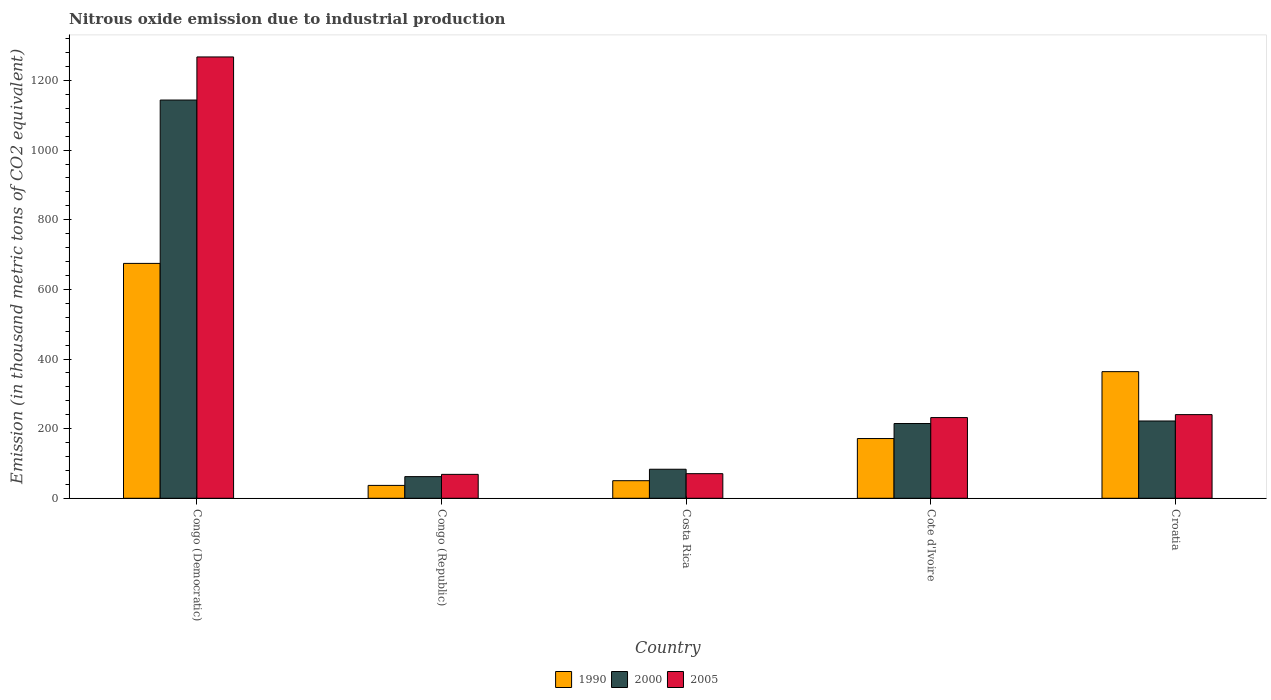Are the number of bars per tick equal to the number of legend labels?
Ensure brevity in your answer.  Yes. Are the number of bars on each tick of the X-axis equal?
Provide a short and direct response. Yes. What is the label of the 4th group of bars from the left?
Keep it short and to the point. Cote d'Ivoire. In how many cases, is the number of bars for a given country not equal to the number of legend labels?
Your answer should be very brief. 0. What is the amount of nitrous oxide emitted in 2000 in Congo (Democratic)?
Your answer should be compact. 1143.8. Across all countries, what is the maximum amount of nitrous oxide emitted in 2005?
Keep it short and to the point. 1267.6. Across all countries, what is the minimum amount of nitrous oxide emitted in 2005?
Your answer should be very brief. 68.7. In which country was the amount of nitrous oxide emitted in 1990 maximum?
Give a very brief answer. Congo (Democratic). In which country was the amount of nitrous oxide emitted in 1990 minimum?
Make the answer very short. Congo (Republic). What is the total amount of nitrous oxide emitted in 2005 in the graph?
Provide a succinct answer. 1879.1. What is the difference between the amount of nitrous oxide emitted in 2005 in Congo (Democratic) and that in Cote d'Ivoire?
Make the answer very short. 1035.8. What is the difference between the amount of nitrous oxide emitted in 2000 in Costa Rica and the amount of nitrous oxide emitted in 1990 in Congo (Republic)?
Keep it short and to the point. 46.4. What is the average amount of nitrous oxide emitted in 1990 per country?
Ensure brevity in your answer.  259.48. What is the difference between the amount of nitrous oxide emitted of/in 1990 and amount of nitrous oxide emitted of/in 2000 in Congo (Democratic)?
Ensure brevity in your answer.  -469.2. What is the ratio of the amount of nitrous oxide emitted in 2000 in Congo (Democratic) to that in Croatia?
Keep it short and to the point. 5.15. Is the amount of nitrous oxide emitted in 2005 in Congo (Democratic) less than that in Congo (Republic)?
Make the answer very short. No. Is the difference between the amount of nitrous oxide emitted in 1990 in Congo (Democratic) and Congo (Republic) greater than the difference between the amount of nitrous oxide emitted in 2000 in Congo (Democratic) and Congo (Republic)?
Offer a very short reply. No. What is the difference between the highest and the second highest amount of nitrous oxide emitted in 2000?
Offer a very short reply. -7.3. What is the difference between the highest and the lowest amount of nitrous oxide emitted in 2005?
Provide a succinct answer. 1198.9. Are all the bars in the graph horizontal?
Make the answer very short. No. What is the difference between two consecutive major ticks on the Y-axis?
Offer a terse response. 200. Are the values on the major ticks of Y-axis written in scientific E-notation?
Provide a short and direct response. No. Where does the legend appear in the graph?
Provide a short and direct response. Bottom center. How are the legend labels stacked?
Your answer should be very brief. Horizontal. What is the title of the graph?
Provide a short and direct response. Nitrous oxide emission due to industrial production. Does "1967" appear as one of the legend labels in the graph?
Provide a succinct answer. No. What is the label or title of the X-axis?
Make the answer very short. Country. What is the label or title of the Y-axis?
Your response must be concise. Emission (in thousand metric tons of CO2 equivalent). What is the Emission (in thousand metric tons of CO2 equivalent) in 1990 in Congo (Democratic)?
Offer a terse response. 674.6. What is the Emission (in thousand metric tons of CO2 equivalent) of 2000 in Congo (Democratic)?
Offer a very short reply. 1143.8. What is the Emission (in thousand metric tons of CO2 equivalent) in 2005 in Congo (Democratic)?
Provide a succinct answer. 1267.6. What is the Emission (in thousand metric tons of CO2 equivalent) in 1990 in Congo (Republic)?
Ensure brevity in your answer.  37. What is the Emission (in thousand metric tons of CO2 equivalent) of 2000 in Congo (Republic)?
Ensure brevity in your answer.  62.2. What is the Emission (in thousand metric tons of CO2 equivalent) in 2005 in Congo (Republic)?
Provide a short and direct response. 68.7. What is the Emission (in thousand metric tons of CO2 equivalent) of 1990 in Costa Rica?
Your response must be concise. 50.5. What is the Emission (in thousand metric tons of CO2 equivalent) of 2000 in Costa Rica?
Make the answer very short. 83.4. What is the Emission (in thousand metric tons of CO2 equivalent) in 2005 in Costa Rica?
Offer a very short reply. 70.7. What is the Emission (in thousand metric tons of CO2 equivalent) in 1990 in Cote d'Ivoire?
Offer a very short reply. 171.6. What is the Emission (in thousand metric tons of CO2 equivalent) in 2000 in Cote d'Ivoire?
Your answer should be compact. 214.7. What is the Emission (in thousand metric tons of CO2 equivalent) in 2005 in Cote d'Ivoire?
Your answer should be very brief. 231.8. What is the Emission (in thousand metric tons of CO2 equivalent) in 1990 in Croatia?
Ensure brevity in your answer.  363.7. What is the Emission (in thousand metric tons of CO2 equivalent) in 2000 in Croatia?
Give a very brief answer. 222. What is the Emission (in thousand metric tons of CO2 equivalent) in 2005 in Croatia?
Your response must be concise. 240.3. Across all countries, what is the maximum Emission (in thousand metric tons of CO2 equivalent) of 1990?
Ensure brevity in your answer.  674.6. Across all countries, what is the maximum Emission (in thousand metric tons of CO2 equivalent) in 2000?
Offer a very short reply. 1143.8. Across all countries, what is the maximum Emission (in thousand metric tons of CO2 equivalent) in 2005?
Offer a very short reply. 1267.6. Across all countries, what is the minimum Emission (in thousand metric tons of CO2 equivalent) of 2000?
Make the answer very short. 62.2. Across all countries, what is the minimum Emission (in thousand metric tons of CO2 equivalent) in 2005?
Your answer should be compact. 68.7. What is the total Emission (in thousand metric tons of CO2 equivalent) in 1990 in the graph?
Your answer should be very brief. 1297.4. What is the total Emission (in thousand metric tons of CO2 equivalent) of 2000 in the graph?
Ensure brevity in your answer.  1726.1. What is the total Emission (in thousand metric tons of CO2 equivalent) in 2005 in the graph?
Keep it short and to the point. 1879.1. What is the difference between the Emission (in thousand metric tons of CO2 equivalent) of 1990 in Congo (Democratic) and that in Congo (Republic)?
Offer a terse response. 637.6. What is the difference between the Emission (in thousand metric tons of CO2 equivalent) of 2000 in Congo (Democratic) and that in Congo (Republic)?
Keep it short and to the point. 1081.6. What is the difference between the Emission (in thousand metric tons of CO2 equivalent) in 2005 in Congo (Democratic) and that in Congo (Republic)?
Your answer should be very brief. 1198.9. What is the difference between the Emission (in thousand metric tons of CO2 equivalent) of 1990 in Congo (Democratic) and that in Costa Rica?
Make the answer very short. 624.1. What is the difference between the Emission (in thousand metric tons of CO2 equivalent) of 2000 in Congo (Democratic) and that in Costa Rica?
Offer a terse response. 1060.4. What is the difference between the Emission (in thousand metric tons of CO2 equivalent) in 2005 in Congo (Democratic) and that in Costa Rica?
Make the answer very short. 1196.9. What is the difference between the Emission (in thousand metric tons of CO2 equivalent) of 1990 in Congo (Democratic) and that in Cote d'Ivoire?
Your response must be concise. 503. What is the difference between the Emission (in thousand metric tons of CO2 equivalent) in 2000 in Congo (Democratic) and that in Cote d'Ivoire?
Provide a short and direct response. 929.1. What is the difference between the Emission (in thousand metric tons of CO2 equivalent) in 2005 in Congo (Democratic) and that in Cote d'Ivoire?
Keep it short and to the point. 1035.8. What is the difference between the Emission (in thousand metric tons of CO2 equivalent) of 1990 in Congo (Democratic) and that in Croatia?
Offer a very short reply. 310.9. What is the difference between the Emission (in thousand metric tons of CO2 equivalent) of 2000 in Congo (Democratic) and that in Croatia?
Keep it short and to the point. 921.8. What is the difference between the Emission (in thousand metric tons of CO2 equivalent) in 2005 in Congo (Democratic) and that in Croatia?
Your answer should be compact. 1027.3. What is the difference between the Emission (in thousand metric tons of CO2 equivalent) of 2000 in Congo (Republic) and that in Costa Rica?
Your answer should be very brief. -21.2. What is the difference between the Emission (in thousand metric tons of CO2 equivalent) in 1990 in Congo (Republic) and that in Cote d'Ivoire?
Your answer should be compact. -134.6. What is the difference between the Emission (in thousand metric tons of CO2 equivalent) of 2000 in Congo (Republic) and that in Cote d'Ivoire?
Offer a terse response. -152.5. What is the difference between the Emission (in thousand metric tons of CO2 equivalent) in 2005 in Congo (Republic) and that in Cote d'Ivoire?
Your response must be concise. -163.1. What is the difference between the Emission (in thousand metric tons of CO2 equivalent) of 1990 in Congo (Republic) and that in Croatia?
Ensure brevity in your answer.  -326.7. What is the difference between the Emission (in thousand metric tons of CO2 equivalent) of 2000 in Congo (Republic) and that in Croatia?
Your response must be concise. -159.8. What is the difference between the Emission (in thousand metric tons of CO2 equivalent) of 2005 in Congo (Republic) and that in Croatia?
Provide a succinct answer. -171.6. What is the difference between the Emission (in thousand metric tons of CO2 equivalent) in 1990 in Costa Rica and that in Cote d'Ivoire?
Offer a terse response. -121.1. What is the difference between the Emission (in thousand metric tons of CO2 equivalent) of 2000 in Costa Rica and that in Cote d'Ivoire?
Make the answer very short. -131.3. What is the difference between the Emission (in thousand metric tons of CO2 equivalent) in 2005 in Costa Rica and that in Cote d'Ivoire?
Your answer should be compact. -161.1. What is the difference between the Emission (in thousand metric tons of CO2 equivalent) of 1990 in Costa Rica and that in Croatia?
Your response must be concise. -313.2. What is the difference between the Emission (in thousand metric tons of CO2 equivalent) of 2000 in Costa Rica and that in Croatia?
Your answer should be compact. -138.6. What is the difference between the Emission (in thousand metric tons of CO2 equivalent) of 2005 in Costa Rica and that in Croatia?
Your response must be concise. -169.6. What is the difference between the Emission (in thousand metric tons of CO2 equivalent) of 1990 in Cote d'Ivoire and that in Croatia?
Provide a succinct answer. -192.1. What is the difference between the Emission (in thousand metric tons of CO2 equivalent) of 1990 in Congo (Democratic) and the Emission (in thousand metric tons of CO2 equivalent) of 2000 in Congo (Republic)?
Give a very brief answer. 612.4. What is the difference between the Emission (in thousand metric tons of CO2 equivalent) of 1990 in Congo (Democratic) and the Emission (in thousand metric tons of CO2 equivalent) of 2005 in Congo (Republic)?
Your answer should be compact. 605.9. What is the difference between the Emission (in thousand metric tons of CO2 equivalent) of 2000 in Congo (Democratic) and the Emission (in thousand metric tons of CO2 equivalent) of 2005 in Congo (Republic)?
Make the answer very short. 1075.1. What is the difference between the Emission (in thousand metric tons of CO2 equivalent) in 1990 in Congo (Democratic) and the Emission (in thousand metric tons of CO2 equivalent) in 2000 in Costa Rica?
Provide a short and direct response. 591.2. What is the difference between the Emission (in thousand metric tons of CO2 equivalent) of 1990 in Congo (Democratic) and the Emission (in thousand metric tons of CO2 equivalent) of 2005 in Costa Rica?
Provide a succinct answer. 603.9. What is the difference between the Emission (in thousand metric tons of CO2 equivalent) in 2000 in Congo (Democratic) and the Emission (in thousand metric tons of CO2 equivalent) in 2005 in Costa Rica?
Your answer should be very brief. 1073.1. What is the difference between the Emission (in thousand metric tons of CO2 equivalent) in 1990 in Congo (Democratic) and the Emission (in thousand metric tons of CO2 equivalent) in 2000 in Cote d'Ivoire?
Your answer should be compact. 459.9. What is the difference between the Emission (in thousand metric tons of CO2 equivalent) of 1990 in Congo (Democratic) and the Emission (in thousand metric tons of CO2 equivalent) of 2005 in Cote d'Ivoire?
Make the answer very short. 442.8. What is the difference between the Emission (in thousand metric tons of CO2 equivalent) of 2000 in Congo (Democratic) and the Emission (in thousand metric tons of CO2 equivalent) of 2005 in Cote d'Ivoire?
Give a very brief answer. 912. What is the difference between the Emission (in thousand metric tons of CO2 equivalent) of 1990 in Congo (Democratic) and the Emission (in thousand metric tons of CO2 equivalent) of 2000 in Croatia?
Provide a short and direct response. 452.6. What is the difference between the Emission (in thousand metric tons of CO2 equivalent) in 1990 in Congo (Democratic) and the Emission (in thousand metric tons of CO2 equivalent) in 2005 in Croatia?
Your response must be concise. 434.3. What is the difference between the Emission (in thousand metric tons of CO2 equivalent) of 2000 in Congo (Democratic) and the Emission (in thousand metric tons of CO2 equivalent) of 2005 in Croatia?
Offer a terse response. 903.5. What is the difference between the Emission (in thousand metric tons of CO2 equivalent) of 1990 in Congo (Republic) and the Emission (in thousand metric tons of CO2 equivalent) of 2000 in Costa Rica?
Provide a succinct answer. -46.4. What is the difference between the Emission (in thousand metric tons of CO2 equivalent) in 1990 in Congo (Republic) and the Emission (in thousand metric tons of CO2 equivalent) in 2005 in Costa Rica?
Offer a very short reply. -33.7. What is the difference between the Emission (in thousand metric tons of CO2 equivalent) in 2000 in Congo (Republic) and the Emission (in thousand metric tons of CO2 equivalent) in 2005 in Costa Rica?
Your response must be concise. -8.5. What is the difference between the Emission (in thousand metric tons of CO2 equivalent) in 1990 in Congo (Republic) and the Emission (in thousand metric tons of CO2 equivalent) in 2000 in Cote d'Ivoire?
Provide a succinct answer. -177.7. What is the difference between the Emission (in thousand metric tons of CO2 equivalent) of 1990 in Congo (Republic) and the Emission (in thousand metric tons of CO2 equivalent) of 2005 in Cote d'Ivoire?
Offer a terse response. -194.8. What is the difference between the Emission (in thousand metric tons of CO2 equivalent) of 2000 in Congo (Republic) and the Emission (in thousand metric tons of CO2 equivalent) of 2005 in Cote d'Ivoire?
Provide a short and direct response. -169.6. What is the difference between the Emission (in thousand metric tons of CO2 equivalent) in 1990 in Congo (Republic) and the Emission (in thousand metric tons of CO2 equivalent) in 2000 in Croatia?
Your answer should be very brief. -185. What is the difference between the Emission (in thousand metric tons of CO2 equivalent) in 1990 in Congo (Republic) and the Emission (in thousand metric tons of CO2 equivalent) in 2005 in Croatia?
Ensure brevity in your answer.  -203.3. What is the difference between the Emission (in thousand metric tons of CO2 equivalent) of 2000 in Congo (Republic) and the Emission (in thousand metric tons of CO2 equivalent) of 2005 in Croatia?
Provide a short and direct response. -178.1. What is the difference between the Emission (in thousand metric tons of CO2 equivalent) of 1990 in Costa Rica and the Emission (in thousand metric tons of CO2 equivalent) of 2000 in Cote d'Ivoire?
Your response must be concise. -164.2. What is the difference between the Emission (in thousand metric tons of CO2 equivalent) of 1990 in Costa Rica and the Emission (in thousand metric tons of CO2 equivalent) of 2005 in Cote d'Ivoire?
Your answer should be very brief. -181.3. What is the difference between the Emission (in thousand metric tons of CO2 equivalent) of 2000 in Costa Rica and the Emission (in thousand metric tons of CO2 equivalent) of 2005 in Cote d'Ivoire?
Provide a short and direct response. -148.4. What is the difference between the Emission (in thousand metric tons of CO2 equivalent) in 1990 in Costa Rica and the Emission (in thousand metric tons of CO2 equivalent) in 2000 in Croatia?
Ensure brevity in your answer.  -171.5. What is the difference between the Emission (in thousand metric tons of CO2 equivalent) in 1990 in Costa Rica and the Emission (in thousand metric tons of CO2 equivalent) in 2005 in Croatia?
Your response must be concise. -189.8. What is the difference between the Emission (in thousand metric tons of CO2 equivalent) of 2000 in Costa Rica and the Emission (in thousand metric tons of CO2 equivalent) of 2005 in Croatia?
Your answer should be compact. -156.9. What is the difference between the Emission (in thousand metric tons of CO2 equivalent) in 1990 in Cote d'Ivoire and the Emission (in thousand metric tons of CO2 equivalent) in 2000 in Croatia?
Keep it short and to the point. -50.4. What is the difference between the Emission (in thousand metric tons of CO2 equivalent) in 1990 in Cote d'Ivoire and the Emission (in thousand metric tons of CO2 equivalent) in 2005 in Croatia?
Your response must be concise. -68.7. What is the difference between the Emission (in thousand metric tons of CO2 equivalent) of 2000 in Cote d'Ivoire and the Emission (in thousand metric tons of CO2 equivalent) of 2005 in Croatia?
Provide a short and direct response. -25.6. What is the average Emission (in thousand metric tons of CO2 equivalent) in 1990 per country?
Provide a short and direct response. 259.48. What is the average Emission (in thousand metric tons of CO2 equivalent) in 2000 per country?
Give a very brief answer. 345.22. What is the average Emission (in thousand metric tons of CO2 equivalent) in 2005 per country?
Your response must be concise. 375.82. What is the difference between the Emission (in thousand metric tons of CO2 equivalent) in 1990 and Emission (in thousand metric tons of CO2 equivalent) in 2000 in Congo (Democratic)?
Provide a short and direct response. -469.2. What is the difference between the Emission (in thousand metric tons of CO2 equivalent) of 1990 and Emission (in thousand metric tons of CO2 equivalent) of 2005 in Congo (Democratic)?
Keep it short and to the point. -593. What is the difference between the Emission (in thousand metric tons of CO2 equivalent) in 2000 and Emission (in thousand metric tons of CO2 equivalent) in 2005 in Congo (Democratic)?
Your answer should be compact. -123.8. What is the difference between the Emission (in thousand metric tons of CO2 equivalent) in 1990 and Emission (in thousand metric tons of CO2 equivalent) in 2000 in Congo (Republic)?
Give a very brief answer. -25.2. What is the difference between the Emission (in thousand metric tons of CO2 equivalent) of 1990 and Emission (in thousand metric tons of CO2 equivalent) of 2005 in Congo (Republic)?
Provide a short and direct response. -31.7. What is the difference between the Emission (in thousand metric tons of CO2 equivalent) in 1990 and Emission (in thousand metric tons of CO2 equivalent) in 2000 in Costa Rica?
Provide a succinct answer. -32.9. What is the difference between the Emission (in thousand metric tons of CO2 equivalent) in 1990 and Emission (in thousand metric tons of CO2 equivalent) in 2005 in Costa Rica?
Your answer should be compact. -20.2. What is the difference between the Emission (in thousand metric tons of CO2 equivalent) in 1990 and Emission (in thousand metric tons of CO2 equivalent) in 2000 in Cote d'Ivoire?
Provide a short and direct response. -43.1. What is the difference between the Emission (in thousand metric tons of CO2 equivalent) in 1990 and Emission (in thousand metric tons of CO2 equivalent) in 2005 in Cote d'Ivoire?
Your response must be concise. -60.2. What is the difference between the Emission (in thousand metric tons of CO2 equivalent) in 2000 and Emission (in thousand metric tons of CO2 equivalent) in 2005 in Cote d'Ivoire?
Keep it short and to the point. -17.1. What is the difference between the Emission (in thousand metric tons of CO2 equivalent) of 1990 and Emission (in thousand metric tons of CO2 equivalent) of 2000 in Croatia?
Provide a succinct answer. 141.7. What is the difference between the Emission (in thousand metric tons of CO2 equivalent) of 1990 and Emission (in thousand metric tons of CO2 equivalent) of 2005 in Croatia?
Your answer should be very brief. 123.4. What is the difference between the Emission (in thousand metric tons of CO2 equivalent) of 2000 and Emission (in thousand metric tons of CO2 equivalent) of 2005 in Croatia?
Offer a very short reply. -18.3. What is the ratio of the Emission (in thousand metric tons of CO2 equivalent) in 1990 in Congo (Democratic) to that in Congo (Republic)?
Give a very brief answer. 18.23. What is the ratio of the Emission (in thousand metric tons of CO2 equivalent) in 2000 in Congo (Democratic) to that in Congo (Republic)?
Make the answer very short. 18.39. What is the ratio of the Emission (in thousand metric tons of CO2 equivalent) of 2005 in Congo (Democratic) to that in Congo (Republic)?
Your answer should be compact. 18.45. What is the ratio of the Emission (in thousand metric tons of CO2 equivalent) of 1990 in Congo (Democratic) to that in Costa Rica?
Provide a succinct answer. 13.36. What is the ratio of the Emission (in thousand metric tons of CO2 equivalent) of 2000 in Congo (Democratic) to that in Costa Rica?
Keep it short and to the point. 13.71. What is the ratio of the Emission (in thousand metric tons of CO2 equivalent) of 2005 in Congo (Democratic) to that in Costa Rica?
Your response must be concise. 17.93. What is the ratio of the Emission (in thousand metric tons of CO2 equivalent) in 1990 in Congo (Democratic) to that in Cote d'Ivoire?
Your answer should be compact. 3.93. What is the ratio of the Emission (in thousand metric tons of CO2 equivalent) of 2000 in Congo (Democratic) to that in Cote d'Ivoire?
Keep it short and to the point. 5.33. What is the ratio of the Emission (in thousand metric tons of CO2 equivalent) in 2005 in Congo (Democratic) to that in Cote d'Ivoire?
Your answer should be compact. 5.47. What is the ratio of the Emission (in thousand metric tons of CO2 equivalent) of 1990 in Congo (Democratic) to that in Croatia?
Your answer should be very brief. 1.85. What is the ratio of the Emission (in thousand metric tons of CO2 equivalent) in 2000 in Congo (Democratic) to that in Croatia?
Give a very brief answer. 5.15. What is the ratio of the Emission (in thousand metric tons of CO2 equivalent) of 2005 in Congo (Democratic) to that in Croatia?
Offer a terse response. 5.28. What is the ratio of the Emission (in thousand metric tons of CO2 equivalent) in 1990 in Congo (Republic) to that in Costa Rica?
Offer a very short reply. 0.73. What is the ratio of the Emission (in thousand metric tons of CO2 equivalent) in 2000 in Congo (Republic) to that in Costa Rica?
Offer a terse response. 0.75. What is the ratio of the Emission (in thousand metric tons of CO2 equivalent) in 2005 in Congo (Republic) to that in Costa Rica?
Offer a terse response. 0.97. What is the ratio of the Emission (in thousand metric tons of CO2 equivalent) of 1990 in Congo (Republic) to that in Cote d'Ivoire?
Provide a succinct answer. 0.22. What is the ratio of the Emission (in thousand metric tons of CO2 equivalent) of 2000 in Congo (Republic) to that in Cote d'Ivoire?
Offer a very short reply. 0.29. What is the ratio of the Emission (in thousand metric tons of CO2 equivalent) in 2005 in Congo (Republic) to that in Cote d'Ivoire?
Offer a very short reply. 0.3. What is the ratio of the Emission (in thousand metric tons of CO2 equivalent) of 1990 in Congo (Republic) to that in Croatia?
Provide a short and direct response. 0.1. What is the ratio of the Emission (in thousand metric tons of CO2 equivalent) in 2000 in Congo (Republic) to that in Croatia?
Offer a very short reply. 0.28. What is the ratio of the Emission (in thousand metric tons of CO2 equivalent) of 2005 in Congo (Republic) to that in Croatia?
Your answer should be very brief. 0.29. What is the ratio of the Emission (in thousand metric tons of CO2 equivalent) in 1990 in Costa Rica to that in Cote d'Ivoire?
Your answer should be very brief. 0.29. What is the ratio of the Emission (in thousand metric tons of CO2 equivalent) of 2000 in Costa Rica to that in Cote d'Ivoire?
Offer a very short reply. 0.39. What is the ratio of the Emission (in thousand metric tons of CO2 equivalent) in 2005 in Costa Rica to that in Cote d'Ivoire?
Your answer should be very brief. 0.3. What is the ratio of the Emission (in thousand metric tons of CO2 equivalent) of 1990 in Costa Rica to that in Croatia?
Make the answer very short. 0.14. What is the ratio of the Emission (in thousand metric tons of CO2 equivalent) of 2000 in Costa Rica to that in Croatia?
Give a very brief answer. 0.38. What is the ratio of the Emission (in thousand metric tons of CO2 equivalent) of 2005 in Costa Rica to that in Croatia?
Your response must be concise. 0.29. What is the ratio of the Emission (in thousand metric tons of CO2 equivalent) of 1990 in Cote d'Ivoire to that in Croatia?
Ensure brevity in your answer.  0.47. What is the ratio of the Emission (in thousand metric tons of CO2 equivalent) in 2000 in Cote d'Ivoire to that in Croatia?
Offer a very short reply. 0.97. What is the ratio of the Emission (in thousand metric tons of CO2 equivalent) of 2005 in Cote d'Ivoire to that in Croatia?
Offer a very short reply. 0.96. What is the difference between the highest and the second highest Emission (in thousand metric tons of CO2 equivalent) of 1990?
Your answer should be very brief. 310.9. What is the difference between the highest and the second highest Emission (in thousand metric tons of CO2 equivalent) in 2000?
Give a very brief answer. 921.8. What is the difference between the highest and the second highest Emission (in thousand metric tons of CO2 equivalent) in 2005?
Make the answer very short. 1027.3. What is the difference between the highest and the lowest Emission (in thousand metric tons of CO2 equivalent) of 1990?
Ensure brevity in your answer.  637.6. What is the difference between the highest and the lowest Emission (in thousand metric tons of CO2 equivalent) of 2000?
Offer a terse response. 1081.6. What is the difference between the highest and the lowest Emission (in thousand metric tons of CO2 equivalent) of 2005?
Ensure brevity in your answer.  1198.9. 